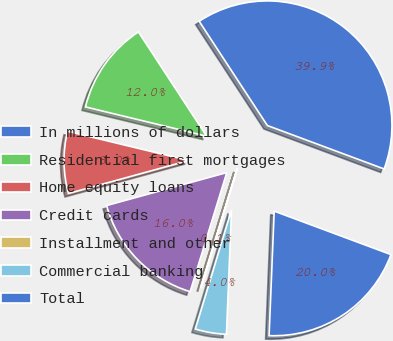<chart> <loc_0><loc_0><loc_500><loc_500><pie_chart><fcel>In millions of dollars<fcel>Residential first mortgages<fcel>Home equity loans<fcel>Credit cards<fcel>Installment and other<fcel>Commercial banking<fcel>Total<nl><fcel>39.89%<fcel>12.01%<fcel>8.03%<fcel>15.99%<fcel>0.06%<fcel>4.04%<fcel>19.98%<nl></chart> 